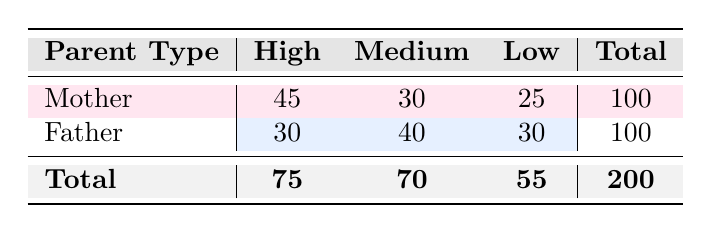What is the total frequency of high involvement by mothers? The table shows that the frequency of high involvement by mothers is 45. This value is found directly in the "High" column for "Mother".
Answer: 45 How many fathers reported a medium level of involvement? The table lists 40 fathers as having a medium level of involvement. This is the frequency found in the "Medium" column for "Father".
Answer: 40 What is the total frequency of low involvement from both parents? To find this, we sum the low involvement frequencies of both parents: 25 (Mother) + 30 (Father) = 55.
Answer: 55 Which parent type has a higher total frequency of involvement? The total frequency for mothers is 100 (45 + 30 + 25) and for fathers, it is also 100 (30 + 40 + 30). Since both are equal, neither has a higher total.
Answer: Neither What percentage of total involvement is attributed to high involvement by mothers? The total frequency for all parents is 200. The frequency of high involvement by mothers is 45. To find the percentage, we divide 45 by 200 and multiply by 100: (45/200) * 100 = 22.5%.
Answer: 22.5% Is it true that more mothers have a high involvement level than fathers? Yes, the frequency for mothers with high involvement is 45, while for fathers, it is 30. This means mothers have a higher level of high involvement than fathers.
Answer: Yes What is the difference in medium involvement levels between mothers and fathers? Mothers have a medium involvement frequency of 30, while fathers have 40. The difference is 40 (Fathers) - 30 (Mothers) = 10.
Answer: 10 What is the total frequency of involvement for mothers? The total for mothers is calculated by adding the frequencies in the row for mothers: 45 (high) + 30 (medium) + 25 (low) = 100.
Answer: 100 How many more fathers have a medium level of involvement compared to those with a low level? We have 40 fathers in the medium category and 30 in the low category. The difference is 40 - 30 = 10.
Answer: 10 